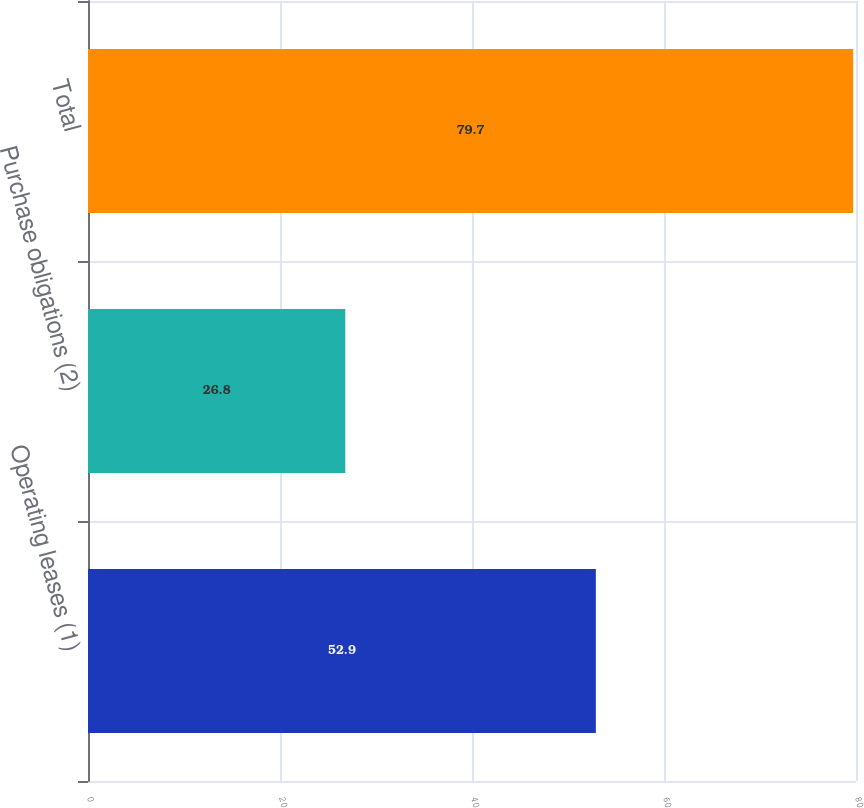<chart> <loc_0><loc_0><loc_500><loc_500><bar_chart><fcel>Operating leases (1)<fcel>Purchase obligations (2)<fcel>Total<nl><fcel>52.9<fcel>26.8<fcel>79.7<nl></chart> 